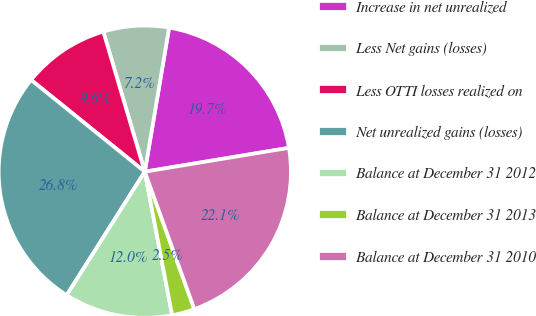Convert chart to OTSL. <chart><loc_0><loc_0><loc_500><loc_500><pie_chart><fcel>Increase in net unrealized<fcel>Less Net gains (losses)<fcel>Less OTTI losses realized on<fcel>Net unrealized gains (losses)<fcel>Balance at December 31 2012<fcel>Balance at December 31 2013<fcel>Balance at December 31 2010<nl><fcel>19.73%<fcel>7.24%<fcel>9.61%<fcel>26.83%<fcel>11.97%<fcel>2.51%<fcel>22.1%<nl></chart> 